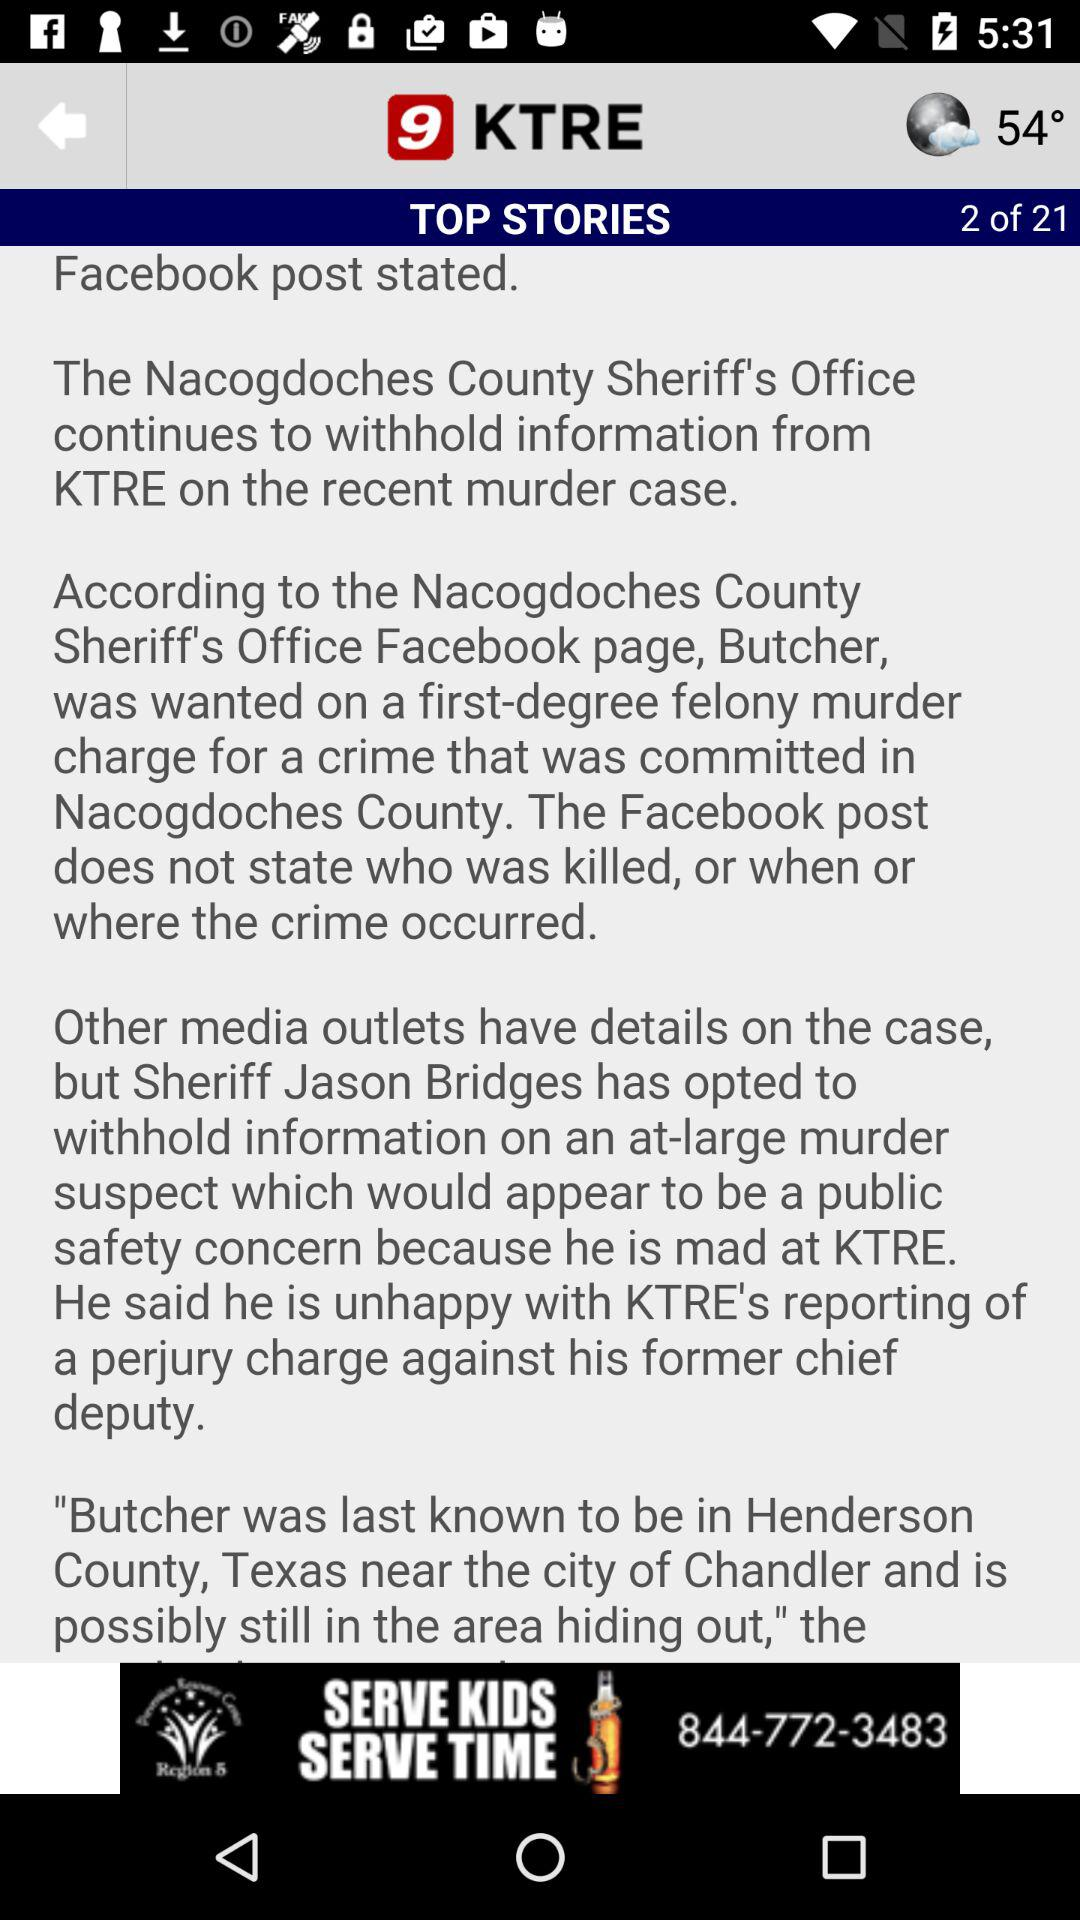What is the temperature? The temperature is 54°. 